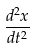<formula> <loc_0><loc_0><loc_500><loc_500>\frac { d ^ { 2 } x } { d t ^ { 2 } }</formula> 